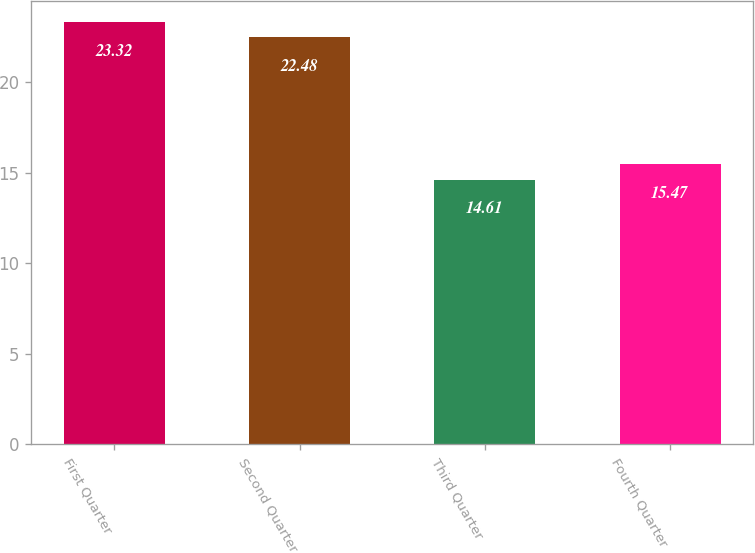<chart> <loc_0><loc_0><loc_500><loc_500><bar_chart><fcel>First Quarter<fcel>Second Quarter<fcel>Third Quarter<fcel>Fourth Quarter<nl><fcel>23.32<fcel>22.48<fcel>14.61<fcel>15.47<nl></chart> 